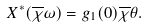<formula> <loc_0><loc_0><loc_500><loc_500>X ^ { \ast } ( \overline { \chi } \omega ) = g _ { 1 } ( 0 ) \overline { \chi } \theta .</formula> 